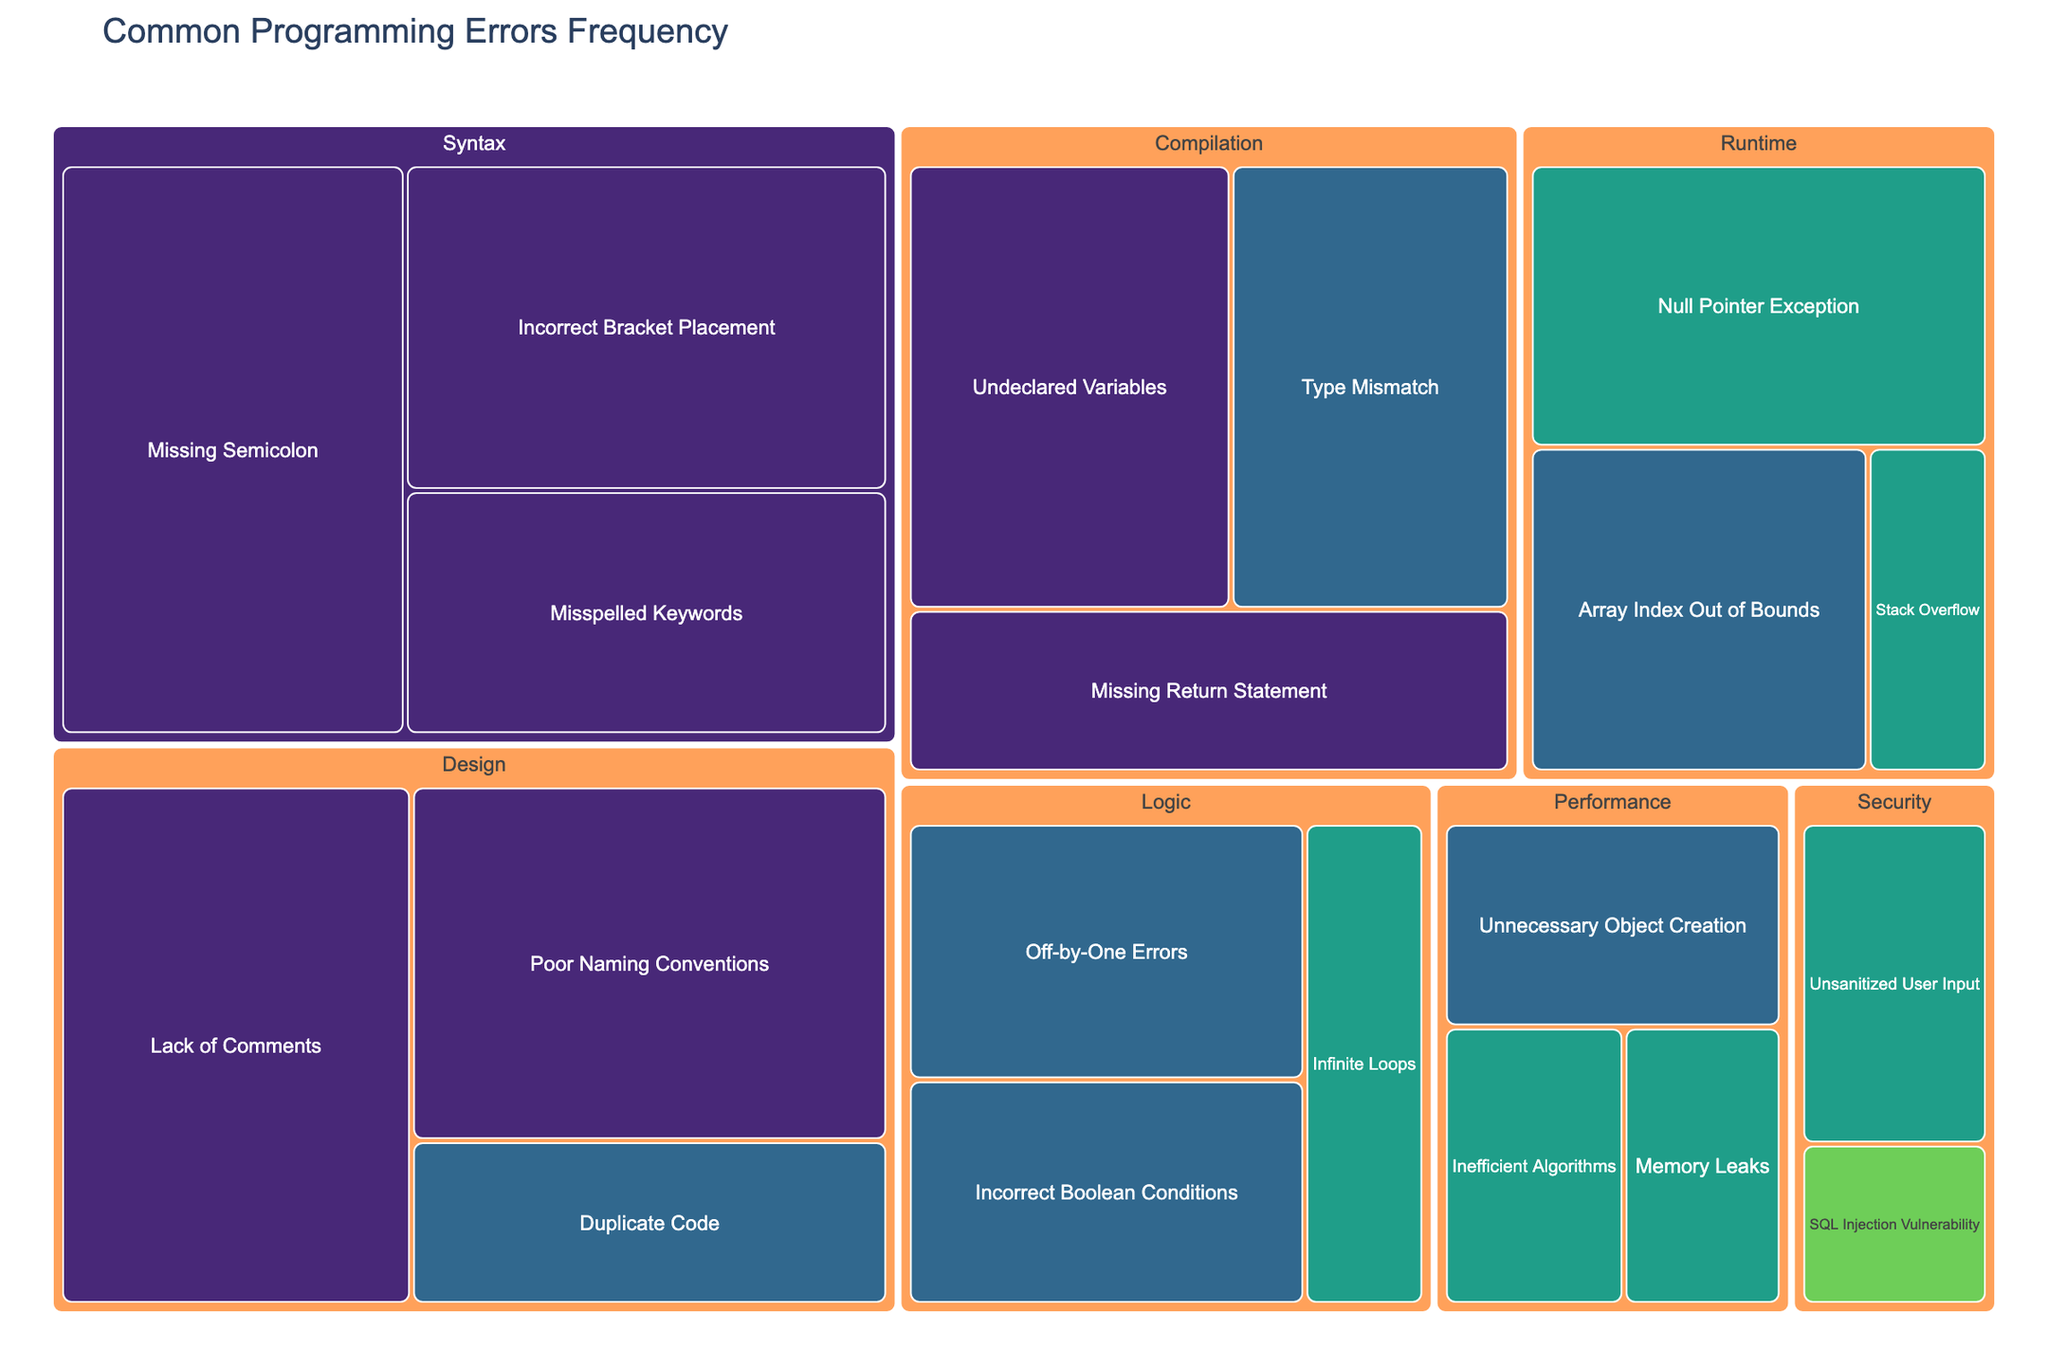What is the most frequent low-severity syntax error? The label for the most frequent low-severity syntax error can be found under the 'Syntax' category and should have the highest frequency count for low severity. Here, 'Missing Semicolon' has a frequency of 150.
Answer: Missing Semicolon Which error type has the highest frequency in the 'Logic' category? To identify the error type with the highest frequency in the 'Logic' category, look at the frequency values for each error type under 'Logic'. 'Off-by-One Errors' has 80, 'Infinite Loops' has 45, and 'Incorrect Boolean Conditions' has 70. Therefore, 'Off-by-One Errors' has the highest frequency.
Answer: Off-by-One Errors How does the frequency of 'Null Pointer Exception' compare to 'Array Index Out of Bounds' in the 'Runtime' category? Compare the frequency values of 'Null Pointer Exception' (100) and 'Array Index Out of Bounds' (85) under the 'Runtime' category. 'Null Pointer Exception' occurs more frequently than 'Array Index Out of Bounds'.
Answer: Null Pointer Exception occurs more frequently What is the combined frequency of high-severity performance errors? The high-severity performance errors are 'Inefficient Algorithms' and 'Memory Leaks'. Add their frequencies: 40 (Inefficient Algorithms) + 35 (Memory Leaks). Thus, the combined frequency is 75.
Answer: 75 Which category has the least frequent critical-severity error, and what is the error type? The critical-severity error can be identified by looking for the 'Critical' label under severity. 'SQL Injection Vulnerability' in the 'Security' category is marked 'Critical' with a frequency of 25.
Answer: Security, SQL Injection Vulnerability What is the total frequency of low-severity errors in the 'Design' category? Identify the low-severity errors under the 'Design' category: 'Poor Naming Conventions' (130) and 'Lack of Comments' (140). Add their frequencies: 130 + 140 = 270.
Answer: 270 Which category has more medium-severity errors: 'Compilation' or 'Performance'? Compare the medium-severity error frequencies under both categories. 'Compilation' has 'Type Mismatch' (95), and 'Performance' has 'Unnecessary Object Creation' (55). The 'Compilation' category has more medium-severity errors.
Answer: Compilation What is the average frequency of high-severity errors in the entire dataset? Identify all high-severity errors and their frequencies: 'Infinite Loops' (45), 'Null Pointer Exception' (100), 'Stack Overflow' (30), 'Inefficient Algorithms' (40), 'Memory Leaks' (35), and 'Unsanitized User Input' (50). Calculate their sum: 45 + 100 + 30 + 40 + 35 + 50 = 300. There are 6 high-severity errors, so the average is 300/6 = 50.
Answer: 50 Which error type has the highest frequency in the 'Runtime' category, and what is its severity? Evaluate the frequencies of error types within 'Runtime': 'Null Pointer Exception' (100), 'Array Index Out of Bounds' (85), and 'Stack Overflow' (30). 'Null Pointer Exception' has the highest frequency. Its severity is 'High'.
Answer: Null Pointer Exception, High 